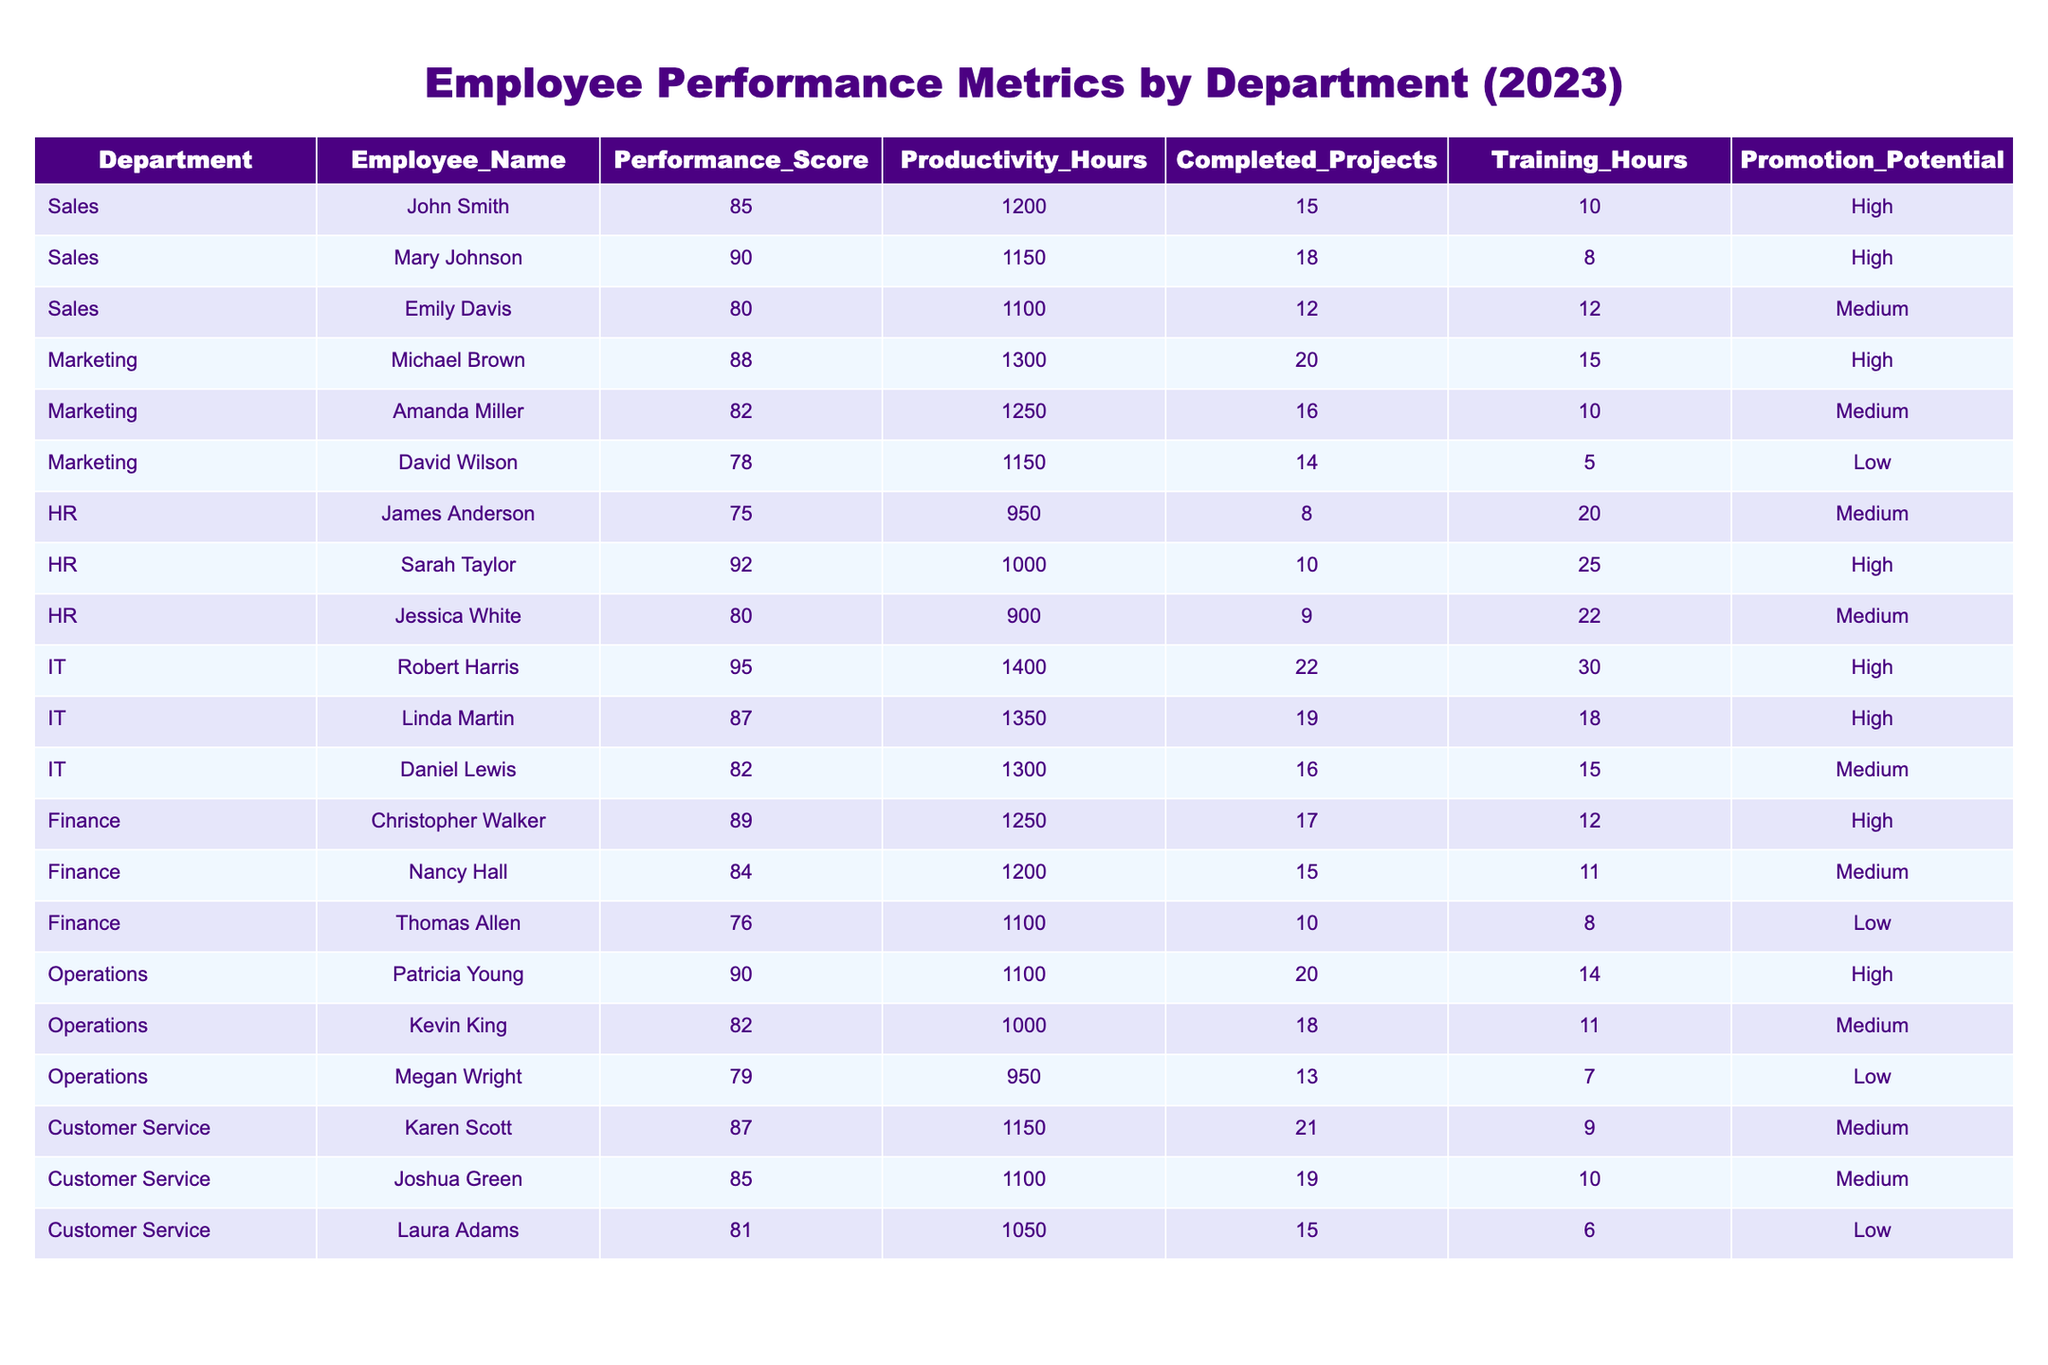What is the highest Performance Score among employees? By scanning the "Performance_Score" column, Robert Harris from the IT department has the highest score of 95.
Answer: 95 Which department has the most employees listed in the table? Counting the employees in each department, Sales has three employees, Marketing has three, HR has three, IT has three, Finance has three, Operations has three, and Customer Service has three. They all have the same number; therefore, there's a tie.
Answer: Tie (3 employees in each department) What is the total number of Completed Projects in the Marketing department? Adding the Completed Projects for the Marketing employees (20 + 16 + 14) results in a total of 50 Completed Projects.
Answer: 50 Who has the lowest Promotion Potential among all employees? Looking through the "Promotion_Potential" column, David Wilson from the Marketing department has the lowest potential, categorized as Low.
Answer: David Wilson What is the average Productivity Hours for employees in the HR department? The productivity hours for HR employees are 950, 1000, and 900. The sum is (950 + 1000 + 900) = 2850. The average is calculated by dividing the sum by the number of employees, which is 2850/3 = 950.
Answer: 950 How many employees in the Customer Service department have a Performance Score above 85? Karen Scott (87) and Joshua Green (85) have scores above 85, while Laura Adams (81) does not. Thus, there are 2 employees with a score above 85.
Answer: 2 What is the difference between the highest and lowest Training Hours among employees? The highest Training Hours is 30 (Robert Harris from IT), and the lowest is 5 (David Wilson from Marketing). The difference is 30 - 5 = 25.
Answer: 25 Are there any employees in the Operations department with a Low Promotion Potential? Checking the "Promotion_Potential" column for the Operations department, Patricia Young has High potential, Kevin King has Medium potential, and Megan Wright has Low potential, which confirms that there is at least one employee with Low potential.
Answer: Yes What is the average Performance Score of employees with High Promotion Potential? Summing up the Performance Scores of employees categorized with High potential (85, 90, 88, 92, 95, 87, 89, and 90) gives 716. Dividing by the number of these employees (8) results in an average of 716/8 = 89.5.
Answer: 89.5 Which department has the employee with the most Completed Projects? Robert Harris in the IT department completed the most projects totaling 22, which is greater than any other values listed for different departments.
Answer: IT 